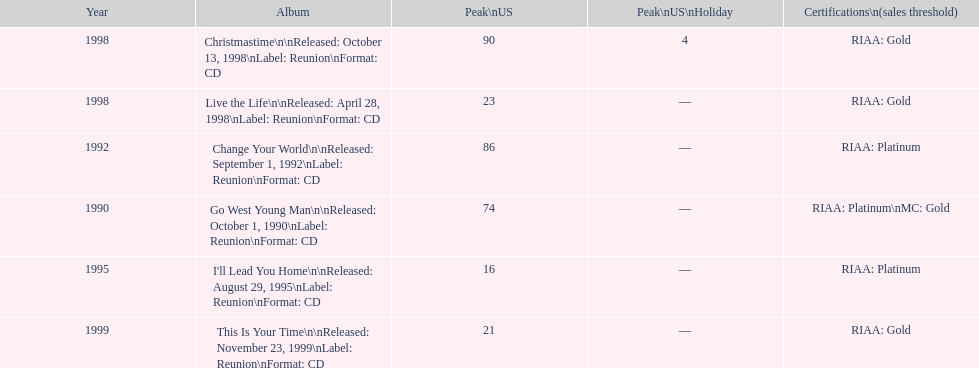Parse the full table. {'header': ['Year', 'Album', 'Peak\\nUS', 'Peak\\nUS\\nHoliday', 'Certifications\\n(sales threshold)'], 'rows': [['1998', 'Christmastime\\n\\nReleased: October 13, 1998\\nLabel: Reunion\\nFormat: CD', '90', '4', 'RIAA: Gold'], ['1998', 'Live the Life\\n\\nReleased: April 28, 1998\\nLabel: Reunion\\nFormat: CD', '23', '—', 'RIAA: Gold'], ['1992', 'Change Your World\\n\\nReleased: September 1, 1992\\nLabel: Reunion\\nFormat: CD', '86', '—', 'RIAA: Platinum'], ['1990', 'Go West Young Man\\n\\nReleased: October 1, 1990\\nLabel: Reunion\\nFormat: CD', '74', '—', 'RIAA: Platinum\\nMC: Gold'], ['1995', "I'll Lead You Home\\n\\nReleased: August 29, 1995\\nLabel: Reunion\\nFormat: CD", '16', '—', 'RIAA: Platinum'], ['1999', 'This Is Your Time\\n\\nReleased: November 23, 1999\\nLabel: Reunion\\nFormat: CD', '21', '—', 'RIAA: Gold']]} What is the number of michael w smith albums that made it to the top 25 of the charts? 3. 